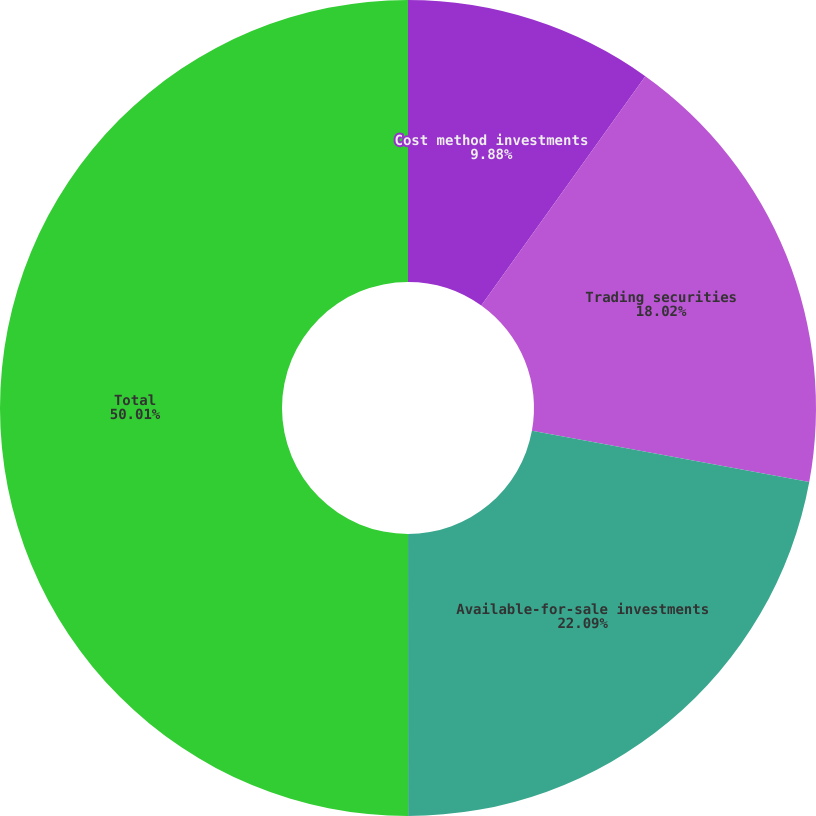<chart> <loc_0><loc_0><loc_500><loc_500><pie_chart><fcel>Cost method investments<fcel>Trading securities<fcel>Available-for-sale investments<fcel>Total<nl><fcel>9.88%<fcel>18.02%<fcel>22.09%<fcel>50.0%<nl></chart> 